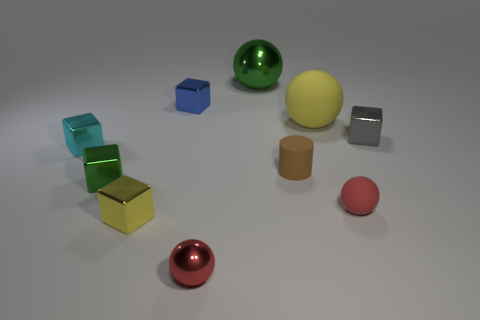Subtract all small shiny balls. How many balls are left? 3 Subtract 2 balls. How many balls are left? 2 Subtract all yellow cubes. How many cubes are left? 4 Subtract all yellow spheres. Subtract all yellow cylinders. How many spheres are left? 3 Subtract all balls. How many objects are left? 6 Subtract all brown matte things. Subtract all small red rubber things. How many objects are left? 8 Add 7 cyan shiny things. How many cyan shiny things are left? 8 Add 8 big gray spheres. How many big gray spheres exist? 8 Subtract 0 purple balls. How many objects are left? 10 